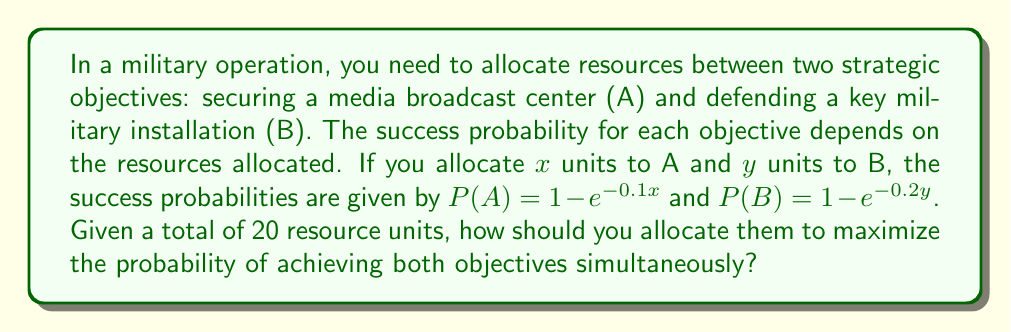Give your solution to this math problem. 1) The probability of achieving both objectives is the product of their individual probabilities:
   $P(A \text{ and } B) = P(A) \cdot P(B) = (1 - e^{-0.1x})(1 - e^{-0.2y})$

2) We need to maximize this function subject to the constraint $x + y = 20$

3) Substitute $y = 20 - x$ into the equation:
   $P(A \text{ and } B) = (1 - e^{-0.1x})(1 - e^{-0.2(20-x)})$

4) To find the maximum, differentiate with respect to $x$ and set to zero:
   $$\frac{d}{dx}[(1 - e^{-0.1x})(1 - e^{-4+0.2x})] = 0$$

5) Solving this equation (which involves complex algebra):
   $$0.1e^{-0.1x}(1 - e^{-4+0.2x}) - 0.2e^{-4+0.2x}(1 - e^{-0.1x}) = 0$$

6) This equation can be simplified to:
   $$e^{0.1x} = 2e^{-4+0.2x}$$

7) Taking logarithms of both sides:
   $$0.1x = \ln 2 - 4 + 0.2x$$

8) Solving for $x$:
   $$x = \frac{\ln 2 - 4}{-0.1} \approx 13.07$$

9) Therefore, $y = 20 - x \approx 6.93$

10) Rounding to whole units: $x = 13$ and $y = 7$
Answer: 13 units to A, 7 units to B 